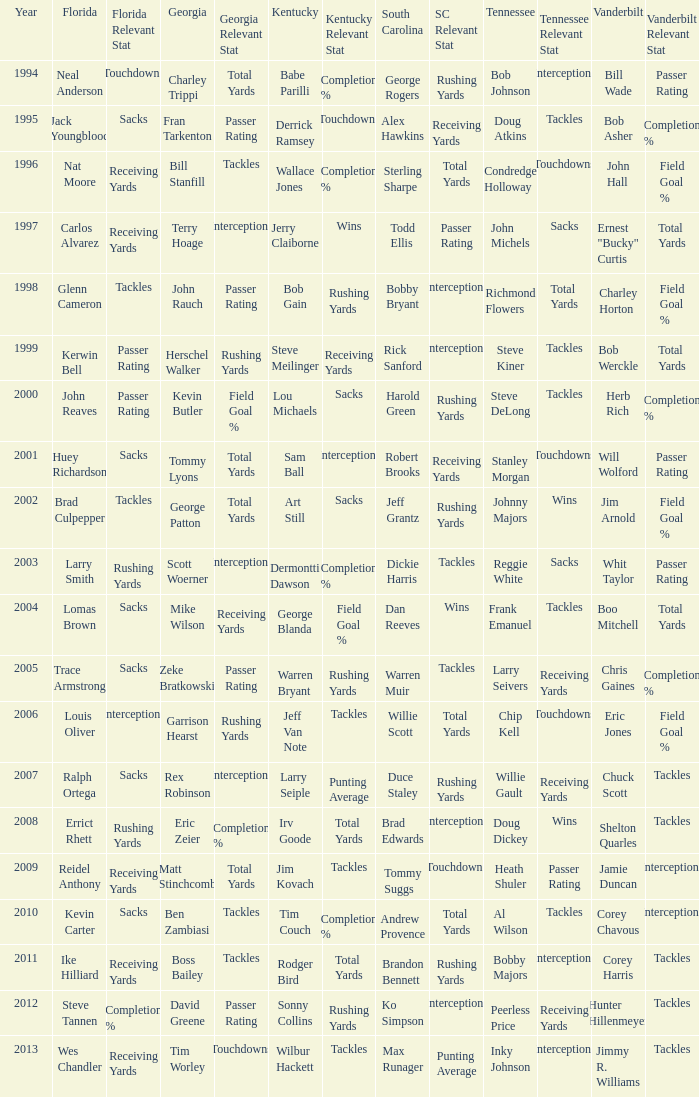I'm looking to parse the entire table for insights. Could you assist me with that? {'header': ['Year', 'Florida', 'Florida Relevant Stat', 'Georgia', 'Georgia Relevant Stat', 'Kentucky', 'Kentucky Relevant Stat', 'South Carolina', 'SC Relevant Stat', 'Tennessee', 'Tennessee Relevant Stat', 'Vanderbilt', 'Vanderbilt Relevant Stat'], 'rows': [['1994', 'Neal Anderson', 'Touchdowns', 'Charley Trippi', 'Total Yards', 'Babe Parilli', 'Completion %', 'George Rogers', 'Rushing Yards', 'Bob Johnson', 'Interceptions', 'Bill Wade', 'Passer Rating'], ['1995', 'Jack Youngblood', 'Sacks', 'Fran Tarkenton', 'Passer Rating', 'Derrick Ramsey', 'Touchdowns', 'Alex Hawkins', 'Receiving Yards', 'Doug Atkins', 'Tackles', 'Bob Asher', 'Completion %'], ['1996', 'Nat Moore', 'Receiving Yards', 'Bill Stanfill', 'Tackles', 'Wallace Jones', 'Completion %', 'Sterling Sharpe', 'Total Yards', 'Condredge Holloway', 'Touchdowns', 'John Hall', 'Field Goal %'], ['1997', 'Carlos Alvarez', 'Receiving Yards', 'Terry Hoage', 'Interceptions', 'Jerry Claiborne', 'Wins', 'Todd Ellis', 'Passer Rating', 'John Michels', 'Sacks', 'Ernest "Bucky" Curtis', 'Total Yards'], ['1998', 'Glenn Cameron', 'Tackles', 'John Rauch', 'Passer Rating', 'Bob Gain', 'Rushing Yards', 'Bobby Bryant', 'Interceptions', 'Richmond Flowers', 'Total Yards', 'Charley Horton', 'Field Goal %'], ['1999', 'Kerwin Bell', 'Passer Rating', 'Herschel Walker', 'Rushing Yards', 'Steve Meilinger', 'Receiving Yards', 'Rick Sanford', 'Interceptions', 'Steve Kiner', 'Tackles', 'Bob Werckle', 'Total Yards'], ['2000', 'John Reaves', 'Passer Rating', 'Kevin Butler', 'Field Goal %', 'Lou Michaels', 'Sacks', 'Harold Green', 'Rushing Yards', 'Steve DeLong', 'Tackles', 'Herb Rich', 'Completion %'], ['2001', 'Huey Richardson', 'Sacks', 'Tommy Lyons', 'Total Yards', 'Sam Ball', 'Interceptions', 'Robert Brooks', 'Receiving Yards', 'Stanley Morgan', 'Touchdowns', 'Will Wolford', 'Passer Rating'], ['2002', 'Brad Culpepper', 'Tackles', 'George Patton', 'Total Yards', 'Art Still', 'Sacks', 'Jeff Grantz', 'Rushing Yards', 'Johnny Majors', 'Wins', 'Jim Arnold', 'Field Goal %'], ['2003', 'Larry Smith', 'Rushing Yards', 'Scott Woerner', 'Interceptions', 'Dermontti Dawson', 'Completion %', 'Dickie Harris', 'Tackles', 'Reggie White', 'Sacks', 'Whit Taylor', 'Passer Rating'], ['2004', 'Lomas Brown', 'Sacks', 'Mike Wilson', 'Receiving Yards', 'George Blanda', 'Field Goal %', 'Dan Reeves', 'Wins', 'Frank Emanuel', 'Tackles', 'Boo Mitchell', 'Total Yards'], ['2005', 'Trace Armstrong', 'Sacks', 'Zeke Bratkowski', 'Passer Rating', 'Warren Bryant', 'Rushing Yards', 'Warren Muir', 'Tackles', 'Larry Seivers', 'Receiving Yards', 'Chris Gaines', 'Completion %'], ['2006', 'Louis Oliver', 'Interceptions', 'Garrison Hearst', 'Rushing Yards', 'Jeff Van Note', 'Tackles', 'Willie Scott', 'Total Yards', 'Chip Kell', 'Touchdowns', 'Eric Jones', 'Field Goal %'], ['2007', 'Ralph Ortega', 'Sacks', 'Rex Robinson', 'Interceptions', 'Larry Seiple', 'Punting Average', 'Duce Staley', 'Rushing Yards', 'Willie Gault', 'Receiving Yards', 'Chuck Scott', 'Tackles'], ['2008', 'Errict Rhett', 'Rushing Yards', 'Eric Zeier', 'Completion %', 'Irv Goode', 'Total Yards', 'Brad Edwards', 'Interceptions', 'Doug Dickey', 'Wins', 'Shelton Quarles', 'Tackles'], ['2009', 'Reidel Anthony', 'Receiving Yards', 'Matt Stinchcomb', 'Total Yards', 'Jim Kovach', 'Tackles', 'Tommy Suggs', 'Touchdowns', 'Heath Shuler', 'Passer Rating', 'Jamie Duncan', 'Interceptions'], ['2010', 'Kevin Carter', 'Sacks', 'Ben Zambiasi', 'Tackles', 'Tim Couch', 'Completion %', 'Andrew Provence', 'Total Yards', 'Al Wilson', 'Tackles', 'Corey Chavous', 'Interceptions'], ['2011', 'Ike Hilliard', 'Receiving Yards', 'Boss Bailey', 'Tackles', 'Rodger Bird', 'Total Yards', 'Brandon Bennett', 'Rushing Yards', 'Bobby Majors', 'Interceptions', 'Corey Harris', 'Tackles'], ['2012', 'Steve Tannen', 'Completion %', 'David Greene', 'Passer Rating', 'Sonny Collins', 'Rushing Yards', 'Ko Simpson', 'Interceptions', 'Peerless Price', 'Receiving Yards', 'Hunter Hillenmeyer', 'Tackles'], ['2013', 'Wes Chandler', 'Receiving Yards', 'Tim Worley', 'Touchdowns', 'Wilbur Hackett', 'Tackles', 'Max Runager', 'Punting Average', 'Inky Johnson', 'Interceptions', 'Jimmy R. Williams', 'Tackles']]} What is the Tennessee with a Kentucky of Larry Seiple Willie Gault. 